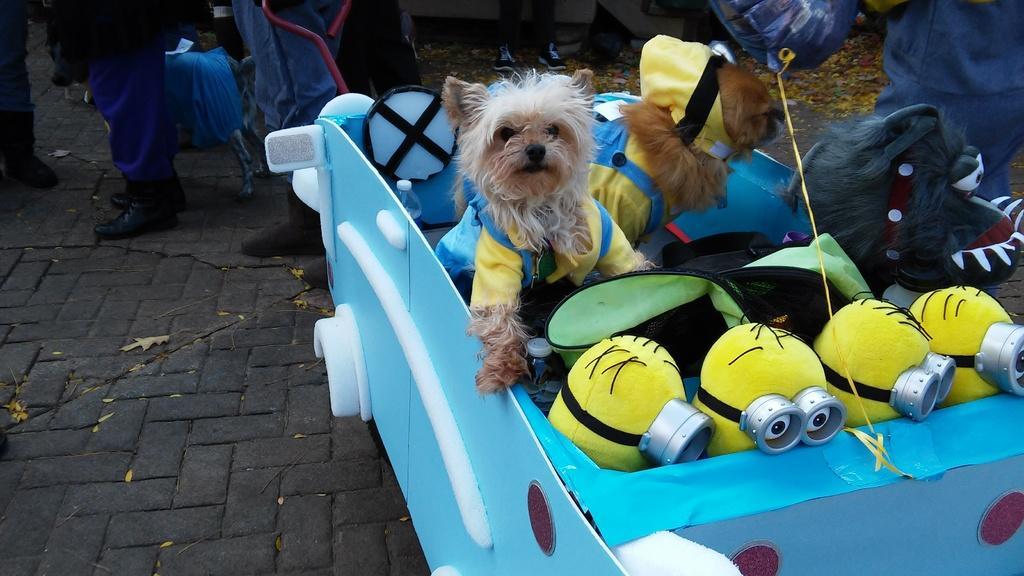Could you give a brief overview of what you see in this image? In this image I can see a dog which is in brown and white color. In front I can see few toys in yellow color, background I can see few other persons some are standing and some are sitting. 